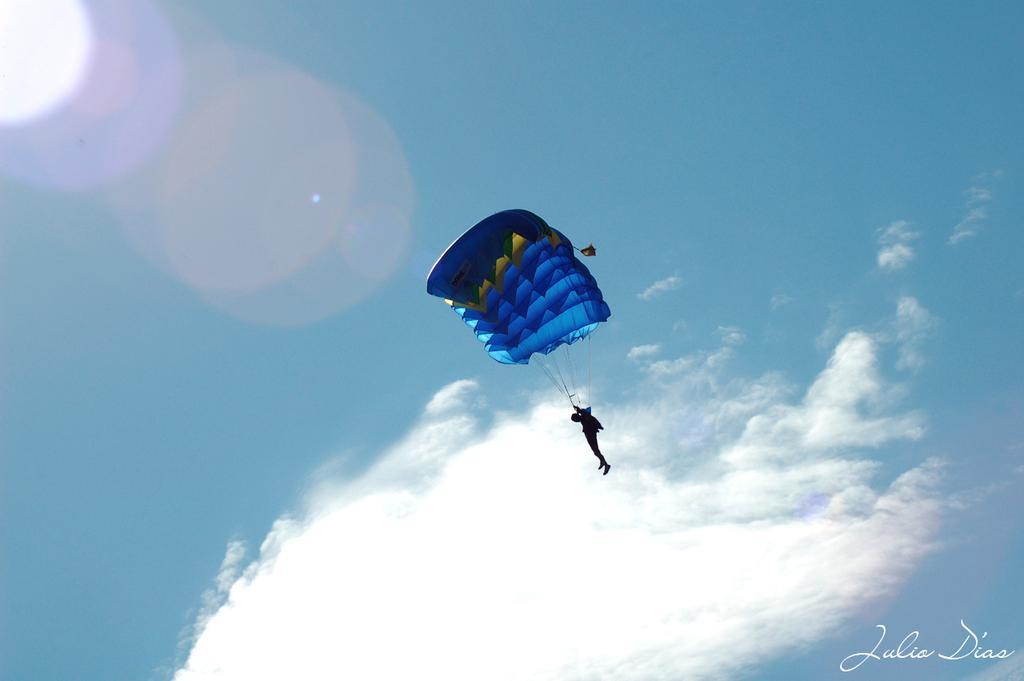In one or two sentences, can you explain what this image depicts? In the center of the picture we can see a person doing para riding. In the background it is sky. The sky is sunny. 